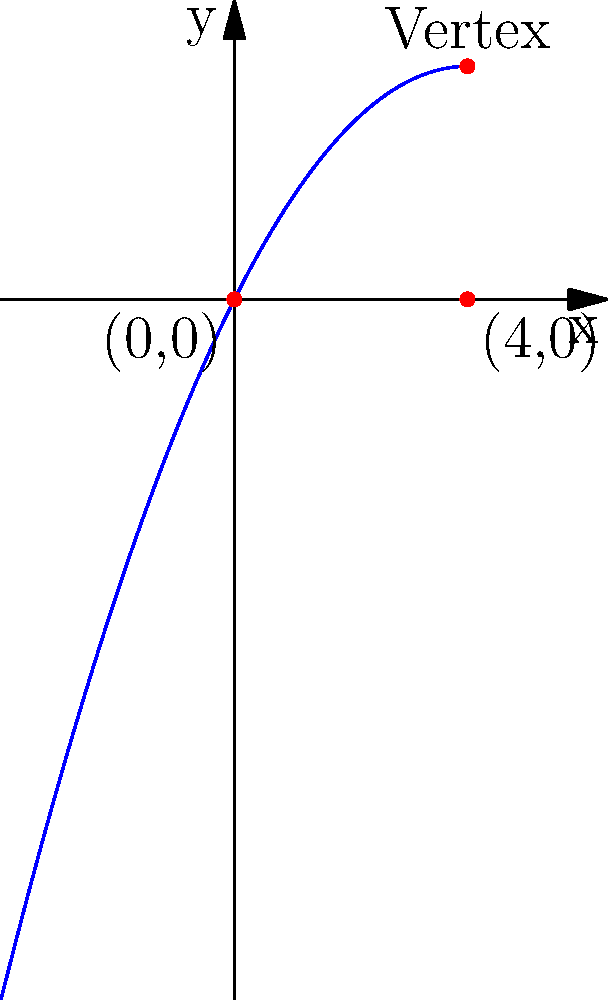In your research on a long-forgotten inventor, you discover documents describing a unique projectile launch. The inventor's notes indicate that the projectile's path forms a parabola, passing through the origin (0,0) and the point (4,0), with its vertex at x = 2. Determine the equation of this parabola in the form $f(x) = ax^2 + bx + c$. Let's approach this step-by-step:

1) The general form of a parabola is $f(x) = ax^2 + bx + c$.

2) We know three key pieces of information:
   a) The parabola passes through (0,0), so $f(0) = 0$
   b) The parabola passes through (4,0), so $f(4) = 0$
   c) The vertex is at x = 2

3) From (a), we can deduce that $c = 0$, as $f(0) = a(0)^2 + b(0) + c = 0$

4) The x-coordinate of the vertex of a parabola is given by $x = -b/(2a)$. Since we know the vertex is at x = 2:

   $2 = -b/(2a)$
   $-4a = b$

5) Now we can use the point (4,0):

   $0 = a(4)^2 + b(4) + 0$
   $0 = 16a + 4b$
   $0 = 16a - 16a$ (substituting $b = -4a$)
   $0 = 0$

   This confirms our equation, but doesn't give us the value of $a$.

6) To find $a$, we can use the fact that the y-coordinate of the vertex is the maximum/minimum point of the parabola. The y-coordinate of the vertex is:

   $y = a(2)^2 + b(2) + c$
   $y = 4a - 8a + 0 = -4a$

7) Since the parabola opens downward (it passes through (0,0) and (4,0) with vertex at x = 2), this y-coordinate must be positive. Let's say the maximum height is 4 units:

   $4 = -4a$
   $a = -1/4 = -0.25$

8) Now we can find $b$:
   $b = -4a = -4(-1/4) = 1$

Therefore, the equation of the parabola is $f(x) = -0.25x^2 + x$.
Answer: $f(x) = -0.25x^2 + x$ 